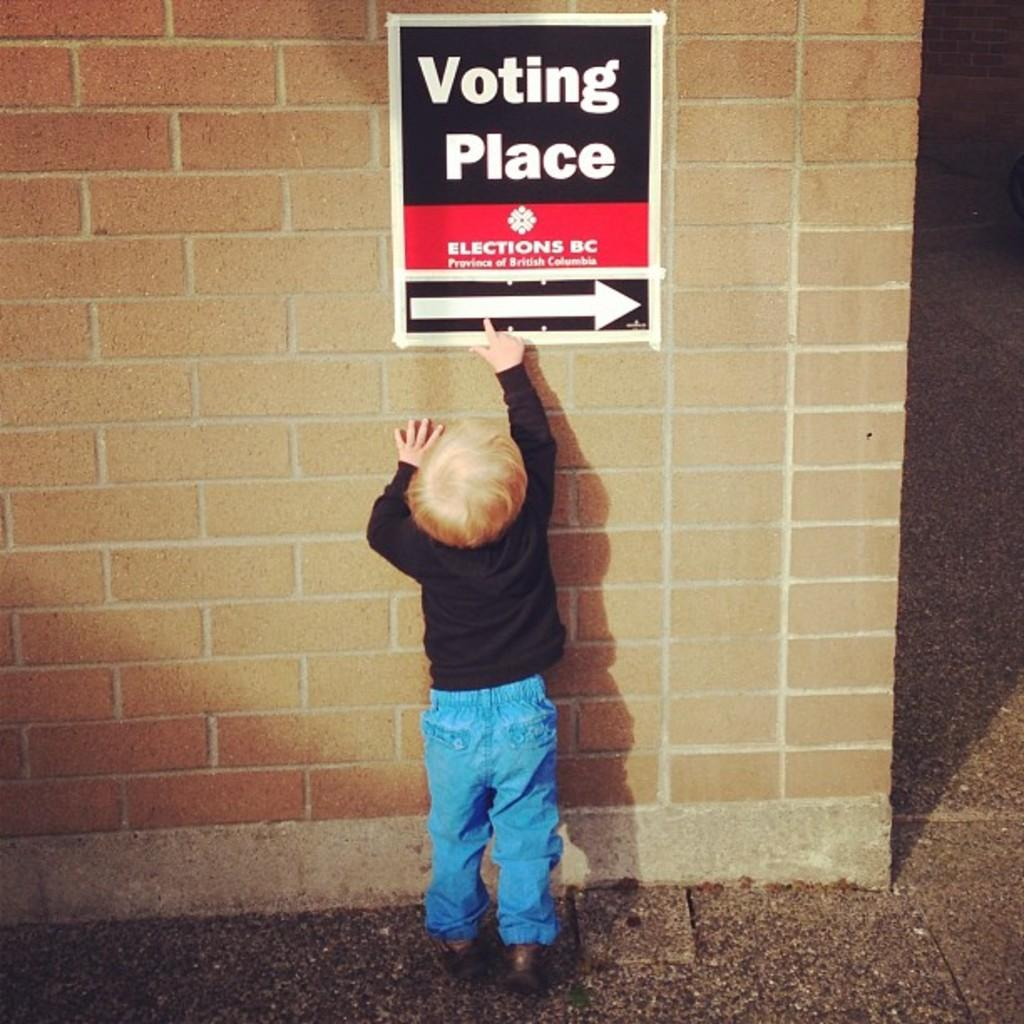What is the main subject of the image? The main subject of the image is a kid. Where is the kid positioned in the image? The kid is standing in front of a wall. What can be seen on the wall in the image? There is a voting poster attached to the wall. What type of texture can be seen on the kid's chin in the image? There is no chin visible in the image, as it only shows a kid standing in front of a wall with a voting poster. 